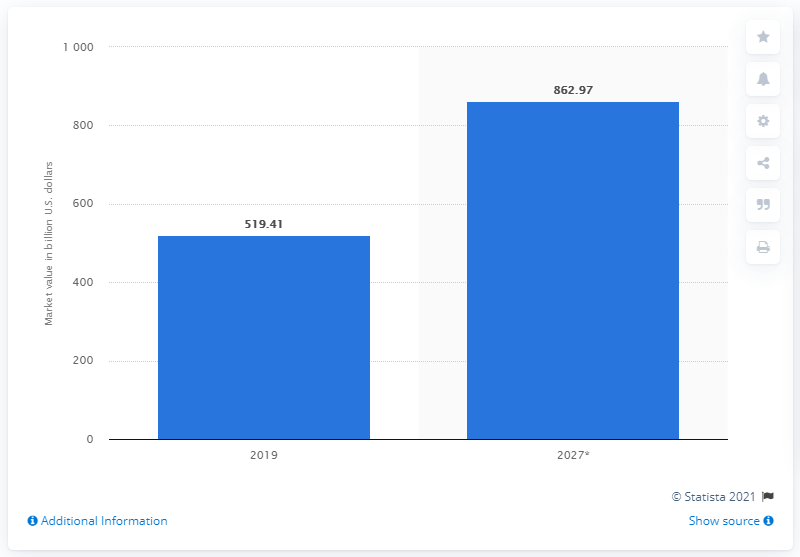Outline some significant characteristics in this image. In 2019, the global market value of processed meat was approximately 519.41 billion dollars. 